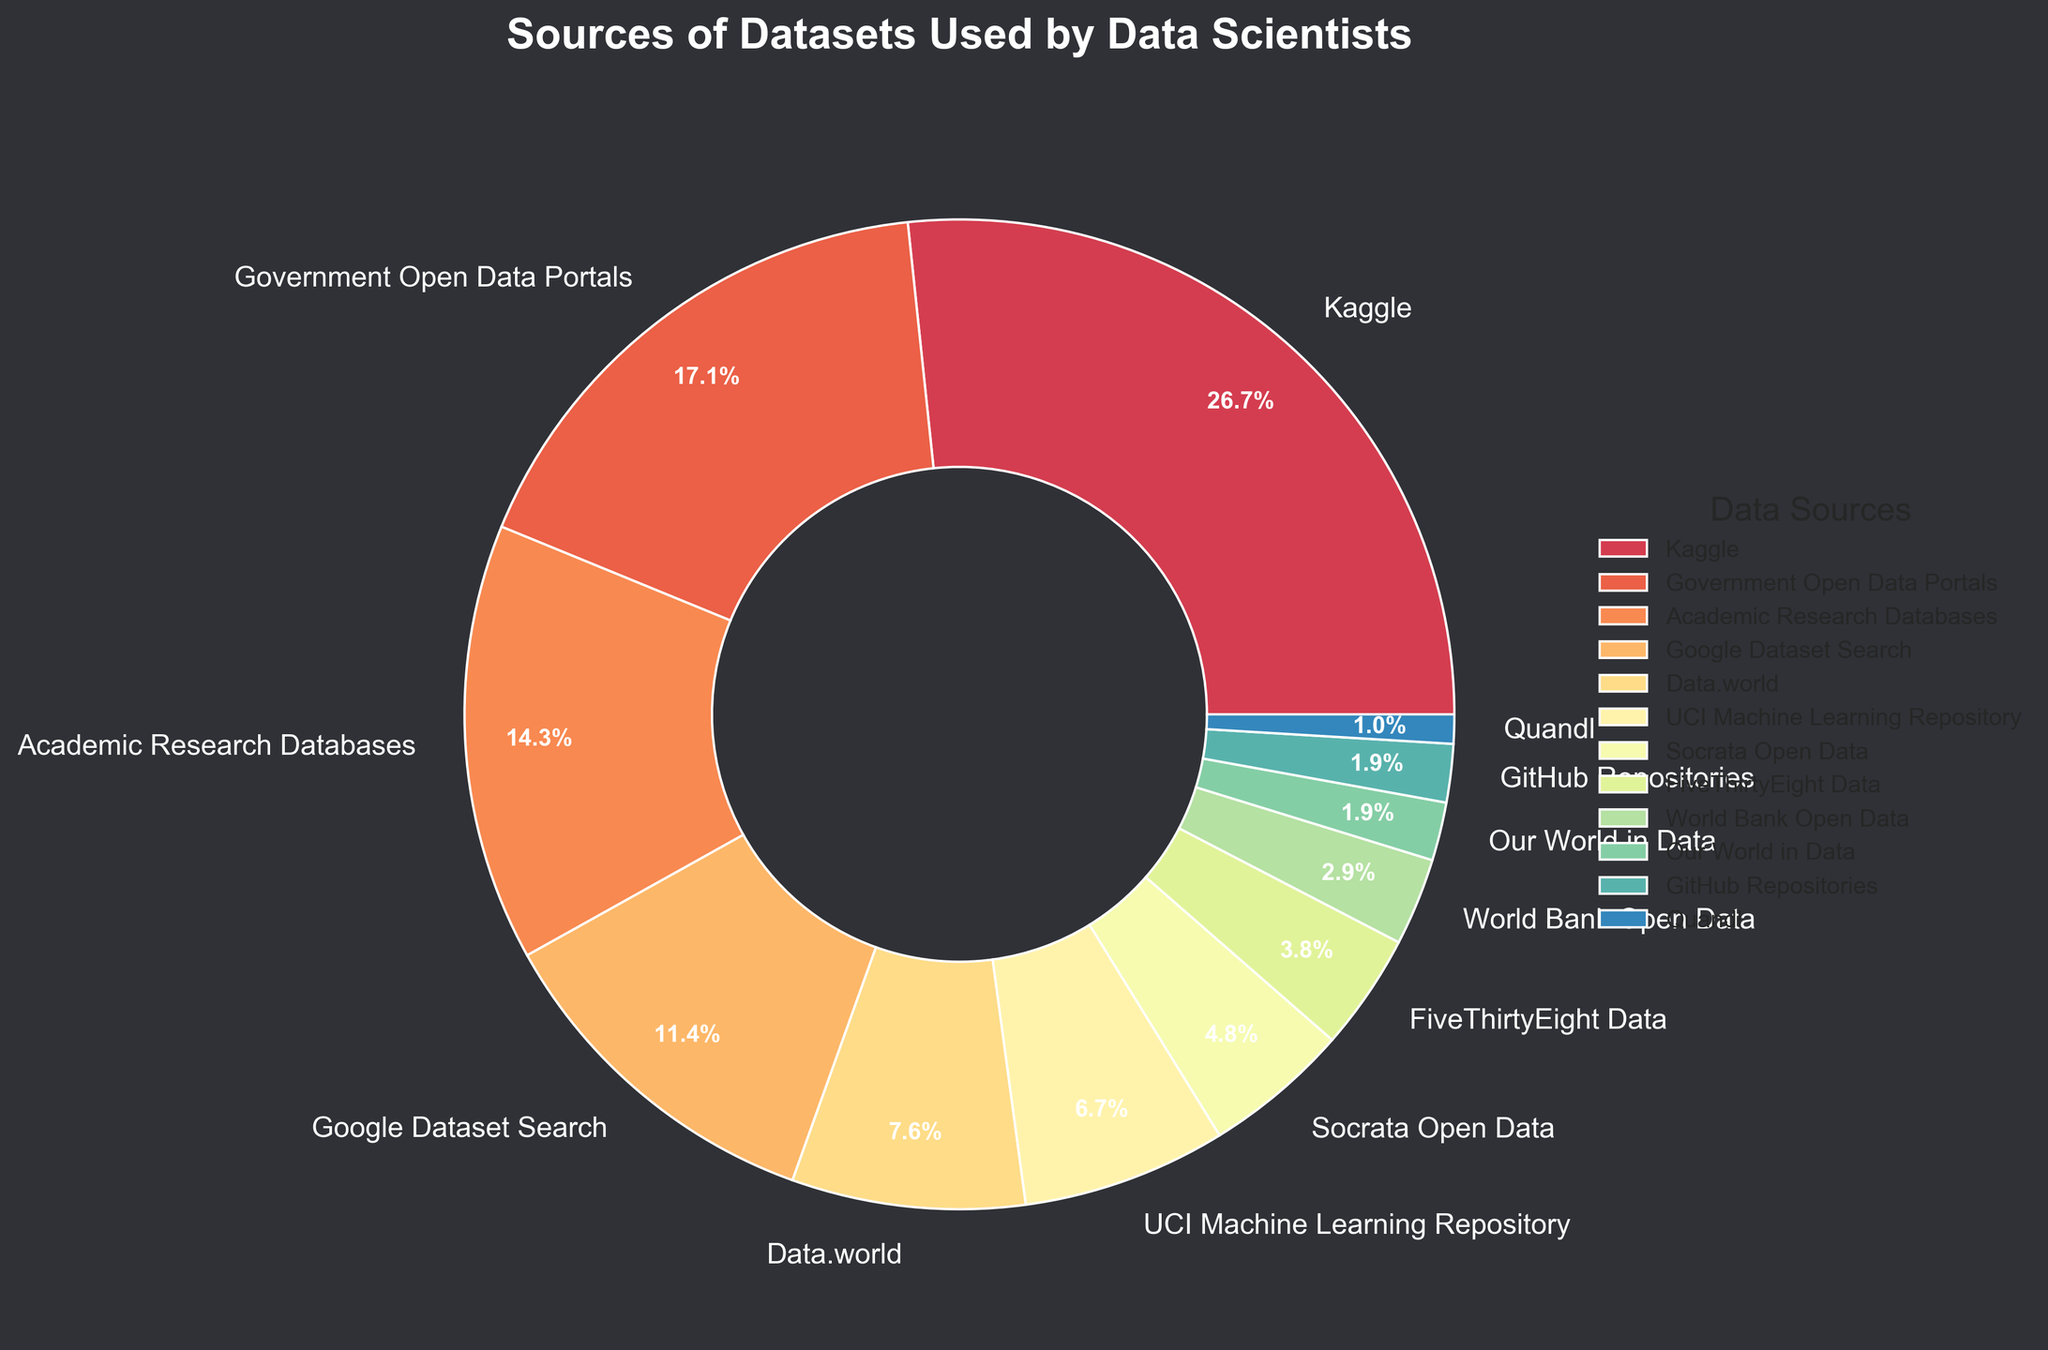Which source provides the highest percentage of datasets used by data scientists? The highest percentage can be identified by finding the largest segment in the pie chart. Kaggle has the largest segment.
Answer: Kaggle What is the combined percentage of datasets provided by Academic Research Databases and Google Dataset Search? To find the combined percentage, add the individual percentages of Academic Research Databases (15%) and Google Dataset Search (12%). The sum is 15 + 12.
Answer: 27% Which source has a smaller percentage of datasets than Socrata Open Data but larger than World Bank Open Data? To determine this, compare the percentage segments. Socrata Open Data has 5%, and World Bank Open Data has 3%. Data.world has 8%, which fits the criteria.
Answer: Data.world How many sources contribute less than 5% each to the total datasets used by data scientists? Identify all segments that are less than 5%. These include FiveThirtyEight Data (4%), World Bank Open Data (3%), Our World in Data (2%), GitHub Repositories (2%), and Quandl (1%). Count these segments.
Answer: 5 What is the percentage difference between the sources with the highest and lowest contributions? Subtract the percentage of the source with the lowest contribution (Quandl, 1%) from the source with the highest contribution (Kaggle, 28%). The difference is 28 - 1.
Answer: 27% Comparing Government Open Data Portals and UCI Machine Learning Repository, which source provides a greater percentage of datasets? Compare the segments representing Government Open Data Portals (18%) and UCI Machine Learning Repository (7%) to see which one is larger.
Answer: Government Open Data Portals If the percentage of datasets from Google Dataset Search doubled, what would be its new percentage, and would it exceed Government Open Data Portals? Double the percentage of Google Dataset Search (12%), which is 12 * 2 = 24%. Government Open Data Portals stands at 18%, so check if 24% exceeds 18%.
Answer: 24%; Yes What percentage of datasets is contributed by sources other than Kaggle, Government Open Data Portals, and Academic Research Databases combined? First, sum up the percentages of Kaggle (28%), Government Open Data Portals (18%), and Academic Research Databases (15%) to get 28 + 18 + 15 = 61%. Subtract this from 100% to find the contribution of the other sources: 100 - 61.
Answer: 39% Among Data.world and Our World in Data, which source contributes the least percentage and by how much? Compare the segments for Data.world (8%) and Our World in Data (2%). Subtract the smaller percentage from the larger one: 8 - 2.
Answer: Our World in Data; 6% What visual attributes stand out for the section representing Kaggle? Observe the Kaggle segment in the pie chart. It is the largest segment, has a prominent color, and takes up a significant portion of the chart.
Answer: Largest; Prominent color 